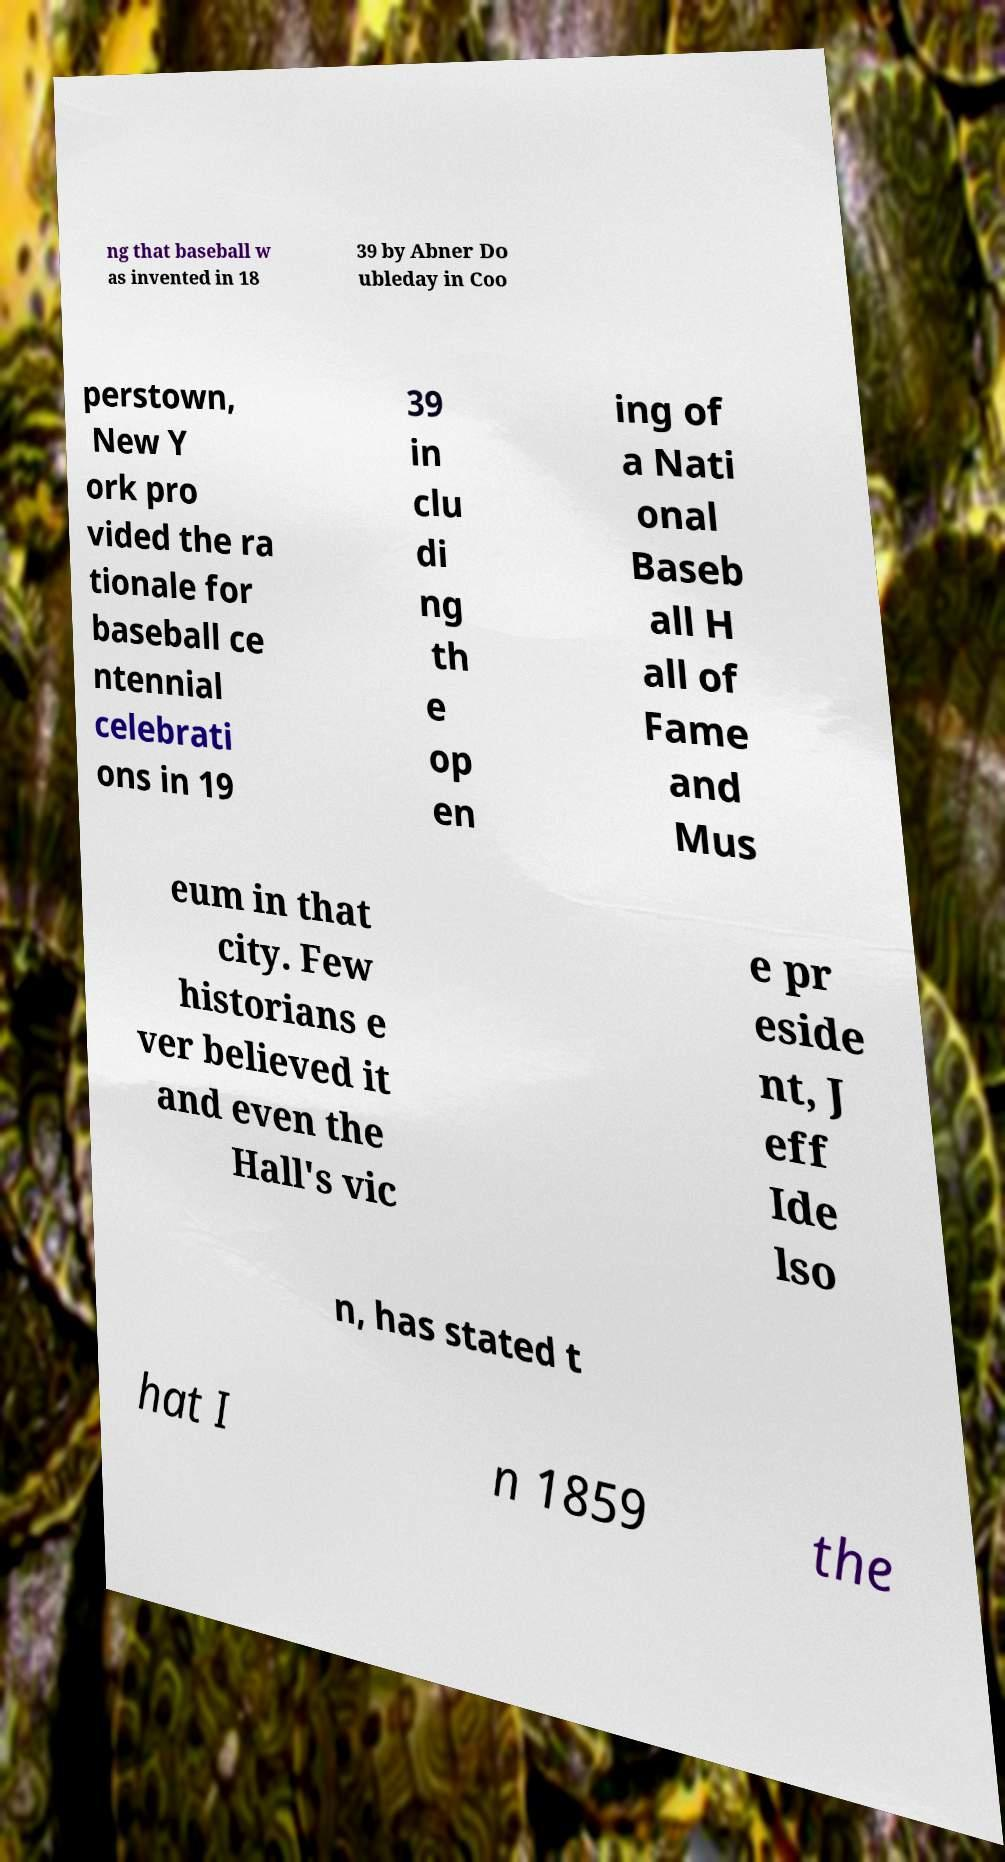What messages or text are displayed in this image? I need them in a readable, typed format. ng that baseball w as invented in 18 39 by Abner Do ubleday in Coo perstown, New Y ork pro vided the ra tionale for baseball ce ntennial celebrati ons in 19 39 in clu di ng th e op en ing of a Nati onal Baseb all H all of Fame and Mus eum in that city. Few historians e ver believed it and even the Hall's vic e pr eside nt, J eff Ide lso n, has stated t hat I n 1859 the 